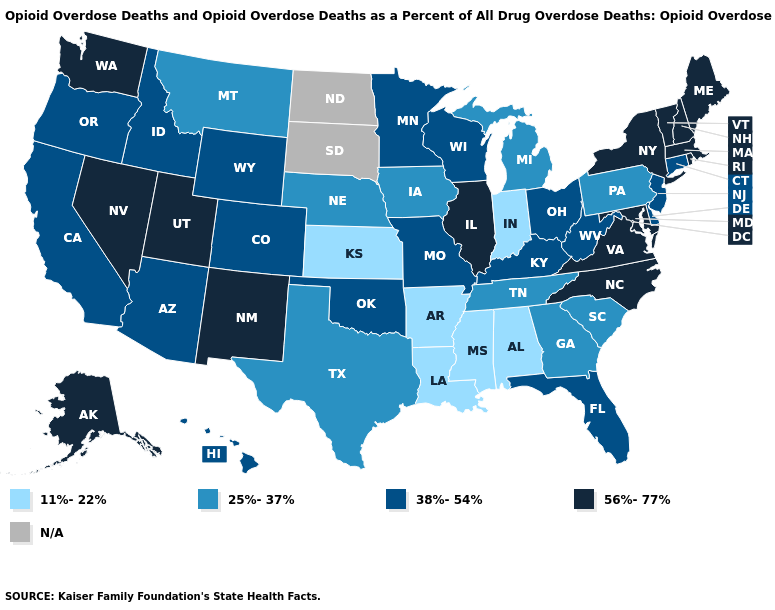What is the value of Kentucky?
Concise answer only. 38%-54%. Does the map have missing data?
Be succinct. Yes. Which states hav the highest value in the MidWest?
Concise answer only. Illinois. Does the map have missing data?
Quick response, please. Yes. Which states have the highest value in the USA?
Be succinct. Alaska, Illinois, Maine, Maryland, Massachusetts, Nevada, New Hampshire, New Mexico, New York, North Carolina, Rhode Island, Utah, Vermont, Virginia, Washington. Name the states that have a value in the range N/A?
Concise answer only. North Dakota, South Dakota. Does North Carolina have the highest value in the South?
Short answer required. Yes. What is the lowest value in states that border Ohio?
Quick response, please. 11%-22%. What is the value of Iowa?
Quick response, please. 25%-37%. Name the states that have a value in the range 11%-22%?
Be succinct. Alabama, Arkansas, Indiana, Kansas, Louisiana, Mississippi. Among the states that border Indiana , does Illinois have the highest value?
Be succinct. Yes. Name the states that have a value in the range 56%-77%?
Write a very short answer. Alaska, Illinois, Maine, Maryland, Massachusetts, Nevada, New Hampshire, New Mexico, New York, North Carolina, Rhode Island, Utah, Vermont, Virginia, Washington. What is the highest value in states that border Oklahoma?
Quick response, please. 56%-77%. Which states have the highest value in the USA?
Keep it brief. Alaska, Illinois, Maine, Maryland, Massachusetts, Nevada, New Hampshire, New Mexico, New York, North Carolina, Rhode Island, Utah, Vermont, Virginia, Washington. What is the value of Texas?
Quick response, please. 25%-37%. 